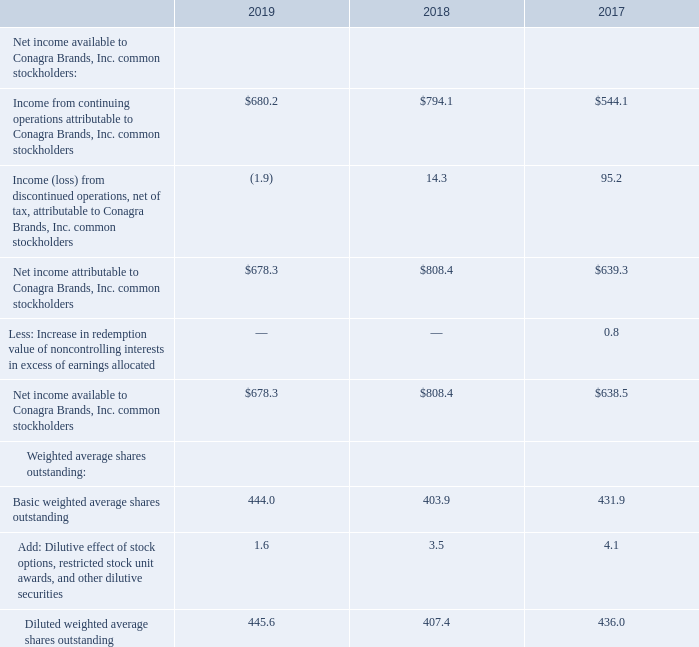Notes to Consolidated Financial Statements - (Continued) Fiscal Years Ended May 26, 2019, May 27, 2018, and May 28, 2017 (columnar dollars in millions except per share amounts)  10. EARNINGS PER SHARE
Basic earnings per share is calculated on the basis of weighted average outstanding shares of common stock. Diluted earnings per share is computed on the basis of basic weighted average outstanding shares of common stock adjusted for the dilutive effect of stock options, restricted stock unit awards, and other dilutive securities. During the second quarter of fiscal 2019, we issued 77.5 million shares of our common stock out of treasury to the former shareholders of Pinnacle pursuant to the terms of the Merger Agreement. In addition, we issued 16.3 million shares of our common stock, par value $5.00 per share, in an underwritten public offering in connection with the financing of the Pinnacle acquisition, with net proceeds of $555.7 million (see Note 2).
The following table reconciles the income and average share amounts used to compute both basic and diluted earnings per share:
For fiscal 2019, 2018, and 2017, there were 2.0 million, 1.3 million, and 0.8 million stock options outstanding, respectively, that were excluded from the computation of diluted weighted average shares because the effect was antidilutive.
How is diluted earnings per share computed? On the basis of basic weighted average outstanding shares of common stock adjusted for the dilutive effect of stock options, restricted stock unit awards, and other dilutive securities. What was the net income available to Conagra Brands, Inc. common stakeholders in fiscal 2017, 2018, and 2019, respectively?
Answer scale should be: million. $638.5, $808.4, $678.3. How much was the basic weighted average shares (in million) outstanding in 2018? 403.9. What is the percentage change in diluted weighted average shares outstanding from 2018 to 2019?
Answer scale should be: percent. (445.6-407.4)/407.4 
Answer: 9.38. What is the ratio of net income available to Conagra Brands, Inc. common stakeholders to diluted weighted average shares outstanding in 2017? 638.5/436.0 
Answer: 1.46. What is the proportion of basic weighted average shares outstanding over diluted weighted average shares outstanding in 2018? 403.9/407.4 
Answer: 0.99. 